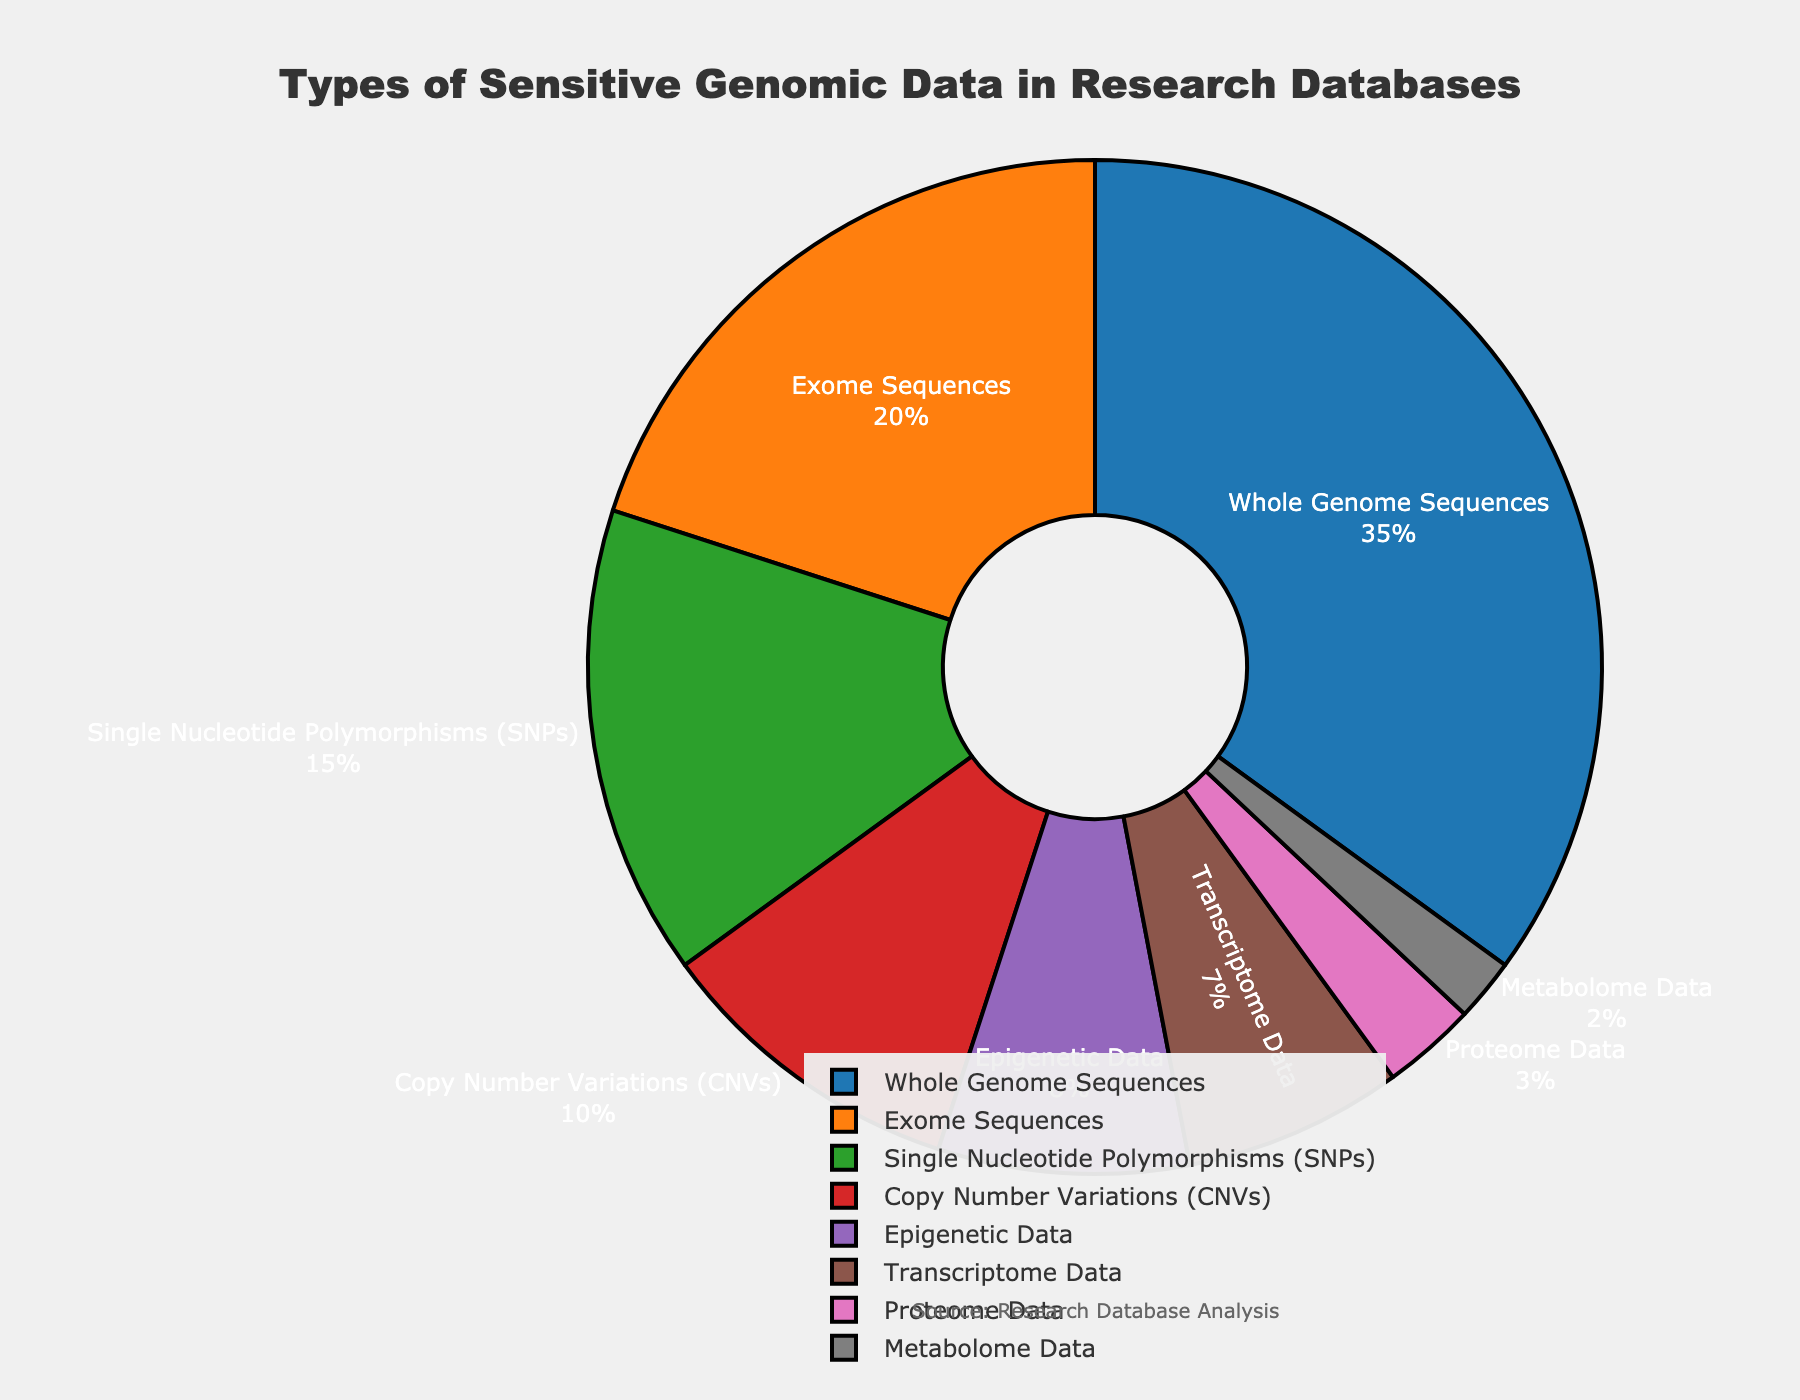Which category has the highest percentage? Find the category with the highest percentage value in the pie chart. Whole Genome Sequences show 35%, which is the highest among all categories.
Answer: Whole Genome Sequences What is the total percentage of Single Nucleotide Polymorphisms (SNPs) and Copy Number Variations (CNVs)? Add the percentage values of Single Nucleotide Polymorphisms (SNPs) and Copy Number Variations (CNVs) from the chart: 15% + 10% = 25%.
Answer: 25% Which category has the smallest representation in the database? Identify the category with the smallest percentage value shown in the pie chart. Metabolome Data shows 2%, the smallest among all categories.
Answer: Metabolome Data How much larger is the percentage of Whole Genome Sequences compared to Transcriptome Data? Subtract the percentage of Transcriptome Data from Whole Genome Sequences: 35% - 7% = 28%.
Answer: 28% Are Epigenetic Data and Transcriptome Data percentages collectively greater than Exome Sequences? Add the percentages of Epigenetic Data and Transcriptome Data and compare the sum to Exome Sequences. 8% + 7% = 15%, which is less than 20% (Exome Sequences).
Answer: No What is the combined percentage for all categories except Whole Genome Sequences and Exome Sequences? Sum the percentages of the categories excluding Whole Genome Sequences and Exome Sequences: 15% (SNPs) + 10% (CNVs) + 8% (Epigenetic Data) + 7% (Transcriptome Data) + 3% (Proteome Data) + 2% (Metabolome Data) = 45%.
Answer: 45% Which category has a percentage nearly close to half of Whole Genome Sequences? Find the category whose percentage is around half of 35% (Whole Genome Sequences). Exome Sequences shows 20%, which is close to half of 35%.
Answer: Exome Sequences What are the third and fourth largest categories by percentage? Identify the categories with the third and fourth largest percentage values from the pie chart. Third is Single Nucleotide Polymorphisms (SNPs) with 15%, and fourth is Copy Number Variations (CNVs) with 10%.
Answer: Single Nucleotide Polymorphisms (SNPs), Copy Number Variations (CNVs) 